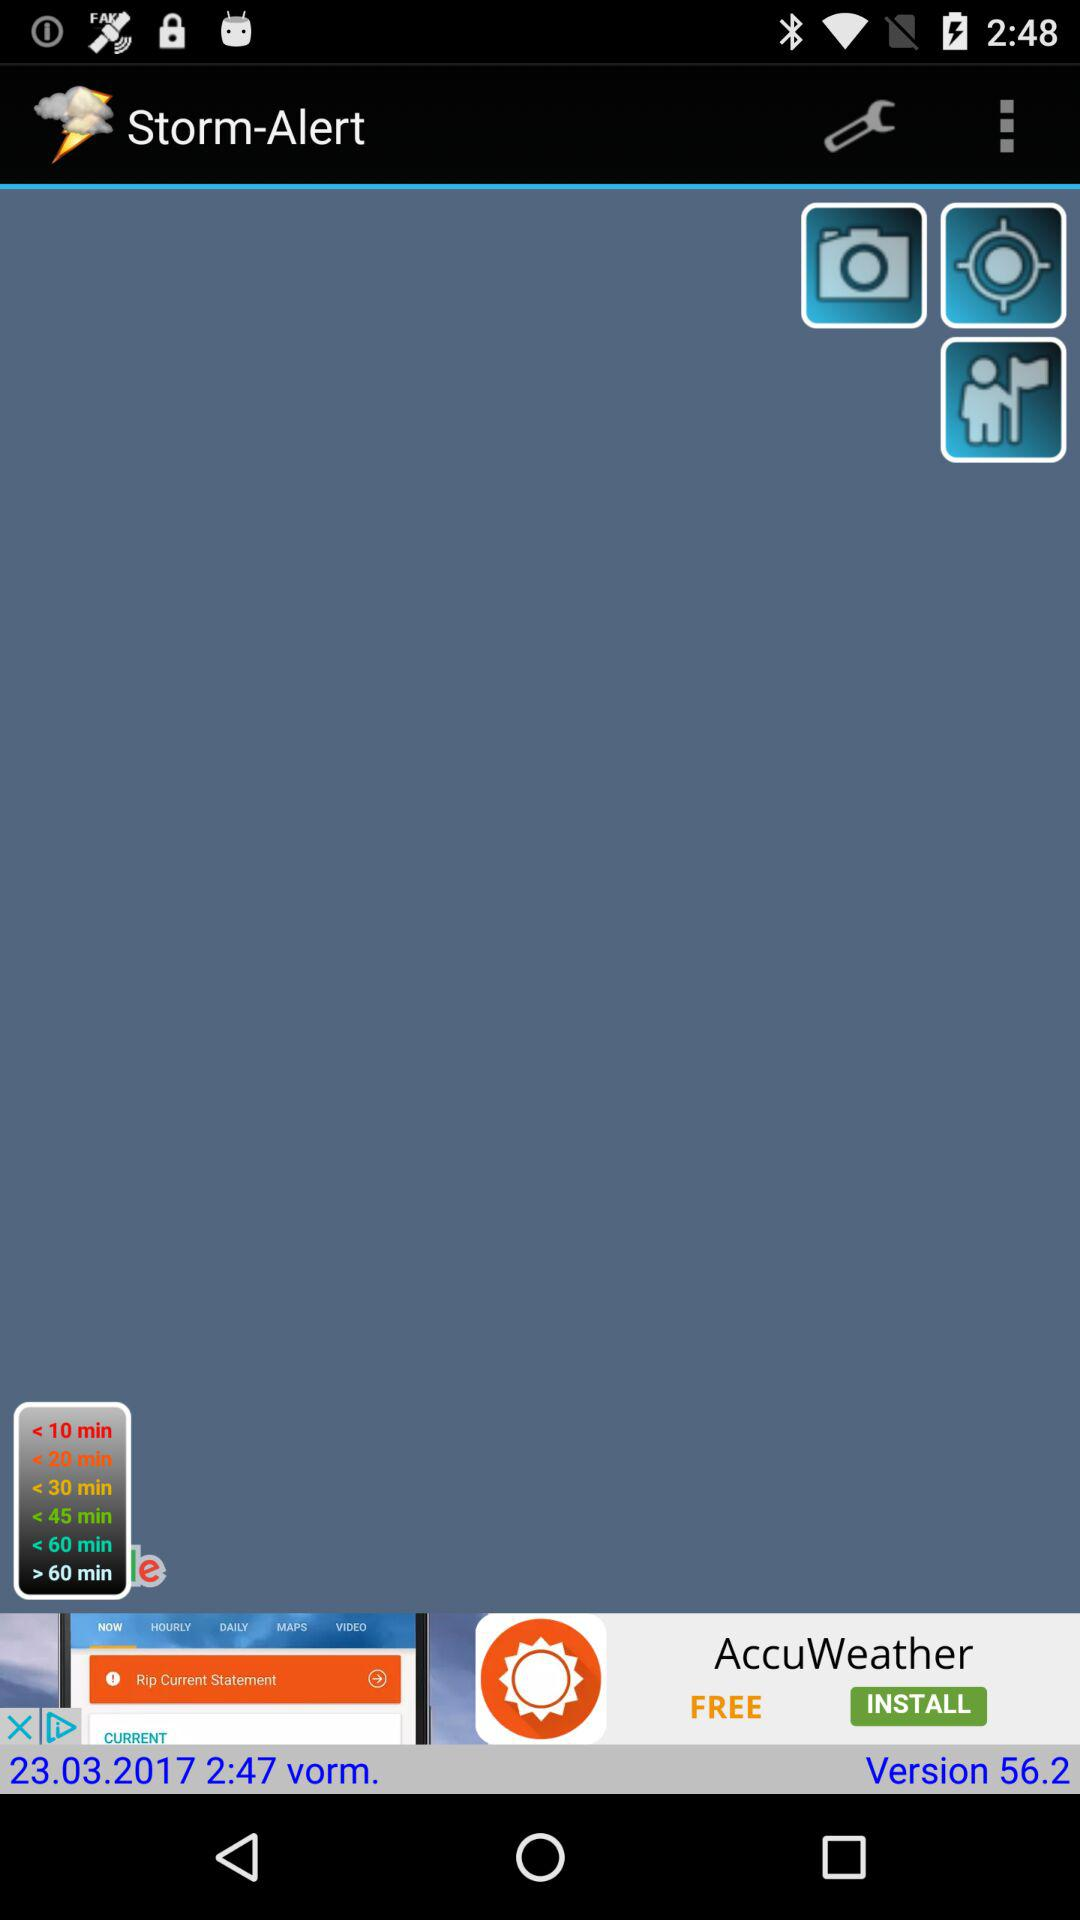What is the version of the app? The version is 56.2. 